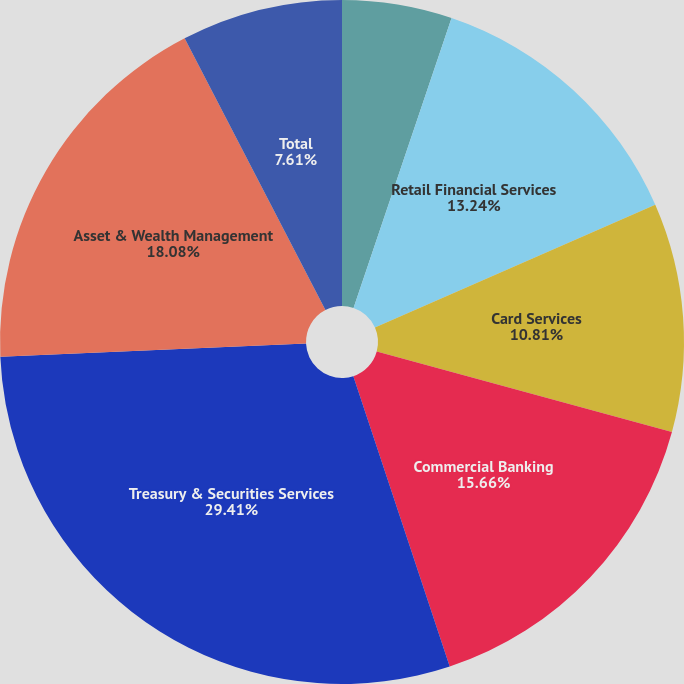Convert chart to OTSL. <chart><loc_0><loc_0><loc_500><loc_500><pie_chart><fcel>Investment Bank<fcel>Retail Financial Services<fcel>Card Services<fcel>Commercial Banking<fcel>Treasury & Securities Services<fcel>Asset & Wealth Management<fcel>Total<nl><fcel>5.19%<fcel>13.24%<fcel>10.81%<fcel>15.66%<fcel>29.41%<fcel>18.08%<fcel>7.61%<nl></chart> 